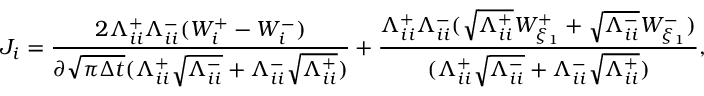<formula> <loc_0><loc_0><loc_500><loc_500>J _ { i } = \frac { 2 \Lambda _ { i i } ^ { + } \Lambda _ { i i } ^ { - } ( W _ { i } ^ { + } - W _ { i } ^ { - } ) } { \partial \sqrt { \pi \Delta t } ( \Lambda _ { i i } ^ { + } \sqrt { \Lambda _ { i i } ^ { - } } + \Lambda _ { i i } ^ { - } \sqrt { \Lambda _ { i i } ^ { + } } ) } + \frac { \Lambda _ { i i } ^ { + } \Lambda _ { i i } ^ { - } ( \sqrt { \Lambda _ { i i } ^ { + } } W _ { \xi _ { 1 } } ^ { + } + \sqrt { \Lambda _ { i i } ^ { - } } W _ { \xi _ { 1 } } ^ { - } ) } { ( \Lambda _ { i i } ^ { + } \sqrt { \Lambda _ { i i } ^ { - } } + \Lambda _ { i i } ^ { - } \sqrt { \Lambda _ { i i } ^ { + } } ) } ,</formula> 